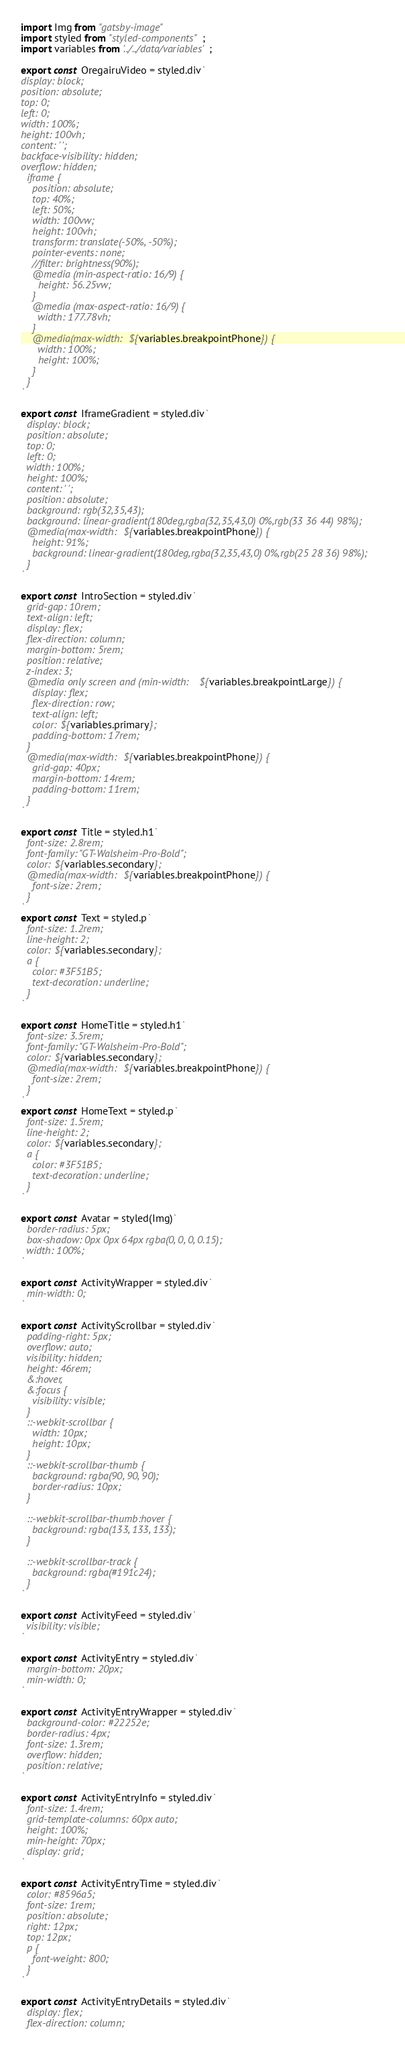Convert code to text. <code><loc_0><loc_0><loc_500><loc_500><_JavaScript_>import Img from "gatsby-image"
import styled from "styled-components";
import variables from '../../data/variables';

export const OregairuVideo = styled.div`
display: block;
position: absolute;
top: 0;
left: 0;
width: 100%;
height: 100vh;
content: ' ';
backface-visibility: hidden;
overflow: hidden;
  iframe {
    position: absolute;
    top: 40%;
    left: 50%;
    width: 100vw;
    height: 100vh;
    transform: translate(-50%, -50%); 
    pointer-events: none;
    //filter: brightness(90%);
    @media (min-aspect-ratio: 16/9) {
      height: 56.25vw;
    }
    @media (max-aspect-ratio: 16/9) {
      width: 177.78vh;
    }
    @media(max-width: ${variables.breakpointPhone}) {
      width: 100%;
      height: 100%;
    }
  }
`

export const IframeGradient = styled.div`
  display: block;
  position: absolute;
  top: 0;
  left: 0;
  width: 100%;
  height: 100%;
  content: ' ';
  position: absolute;
  background: rgb(32,35,43);
  background: linear-gradient(180deg,rgba(32,35,43,0) 0%,rgb(33 36 44) 98%);  
  @media(max-width: ${variables.breakpointPhone}) {
    height: 91%;
    background: linear-gradient(180deg,rgba(32,35,43,0) 0%,rgb(25 28 36) 98%);
  }
`

export const IntroSection = styled.div`
  grid-gap: 10rem;  
  text-align: left;
  display: flex;
  flex-direction: column;
  margin-bottom: 5rem;
  position: relative;
  z-index: 3;
  @media only screen and (min-width: ${variables.breakpointLarge}) {
    display: flex;
    flex-direction: row;
    text-align: left;
    color: ${variables.primary};
    padding-bottom: 17rem;
  }   
  @media(max-width: ${variables.breakpointPhone}) {
    grid-gap: 40px;
    margin-bottom: 14rem;
    padding-bottom: 11rem;
  }
`

export const Title = styled.h1`
  font-size: 2.8rem;
  font-family: "GT-Walsheim-Pro-Bold";
  color: ${variables.secondary};
  @media(max-width: ${variables.breakpointPhone}) {
    font-size: 2rem;
  }
`
export const Text = styled.p`
  font-size: 1.2rem;
  line-height: 2;
  color: ${variables.secondary};
  a {
    color: #3F51B5;
    text-decoration: underline;
  }
`

export const HomeTitle = styled.h1`
  font-size: 3.5rem;
  font-family: "GT-Walsheim-Pro-Bold";
  color: ${variables.secondary};
  @media(max-width: ${variables.breakpointPhone}) {
    font-size: 2rem;
  }
`
export const HomeText = styled.p`
  font-size: 1.5rem;
  line-height: 2;
  color: ${variables.secondary};
  a {
    color: #3F51B5;
    text-decoration: underline;
  }
`

export const Avatar = styled(Img)`
  border-radius: 5px;
  box-shadow: 0px 0px 64px rgba(0, 0, 0, 0.15);
  width: 100%;
`

export const ActivityWrapper = styled.div`
  min-width: 0;
`

export const ActivityScrollbar = styled.div`
  padding-right: 5px;
  overflow: auto;
  visibility: hidden;
  height: 46rem;
  &:hover,
  &:focus {
    visibility: visible;
  }
  ::-webkit-scrollbar {
    width: 10px;
    height: 10px;
  } 
  ::-webkit-scrollbar-thumb {
    background: rgba(90, 90, 90);
    border-radius: 10px;
  }

  ::-webkit-scrollbar-thumb:hover {
    background: rgba(133, 133, 133);
  }

  ::-webkit-scrollbar-track {
    background: rgba(#191c24);
  }
`

export const ActivityFeed = styled.div`
  visibility: visible;
`

export const ActivityEntry = styled.div`
  margin-bottom: 20px;
  min-width: 0;
`

export const ActivityEntryWrapper = styled.div`
  background-color: #22252e;
  border-radius: 4px;
  font-size: 1.3rem;
  overflow: hidden;
  position: relative;
`

export const ActivityEntryInfo = styled.div`
  font-size: 1.4rem;
  grid-template-columns: 60px auto;
  height: 100%;
  min-height: 70px;
  display: grid;
`

export const ActivityEntryTime = styled.div`
  color: #8596a5;
  font-size: 1rem;
  position: absolute;
  right: 12px;
  top: 12px;
  p {
    font-weight: 800;
  }
`

export const ActivityEntryDetails = styled.div`
  display: flex;
  flex-direction: column;</code> 